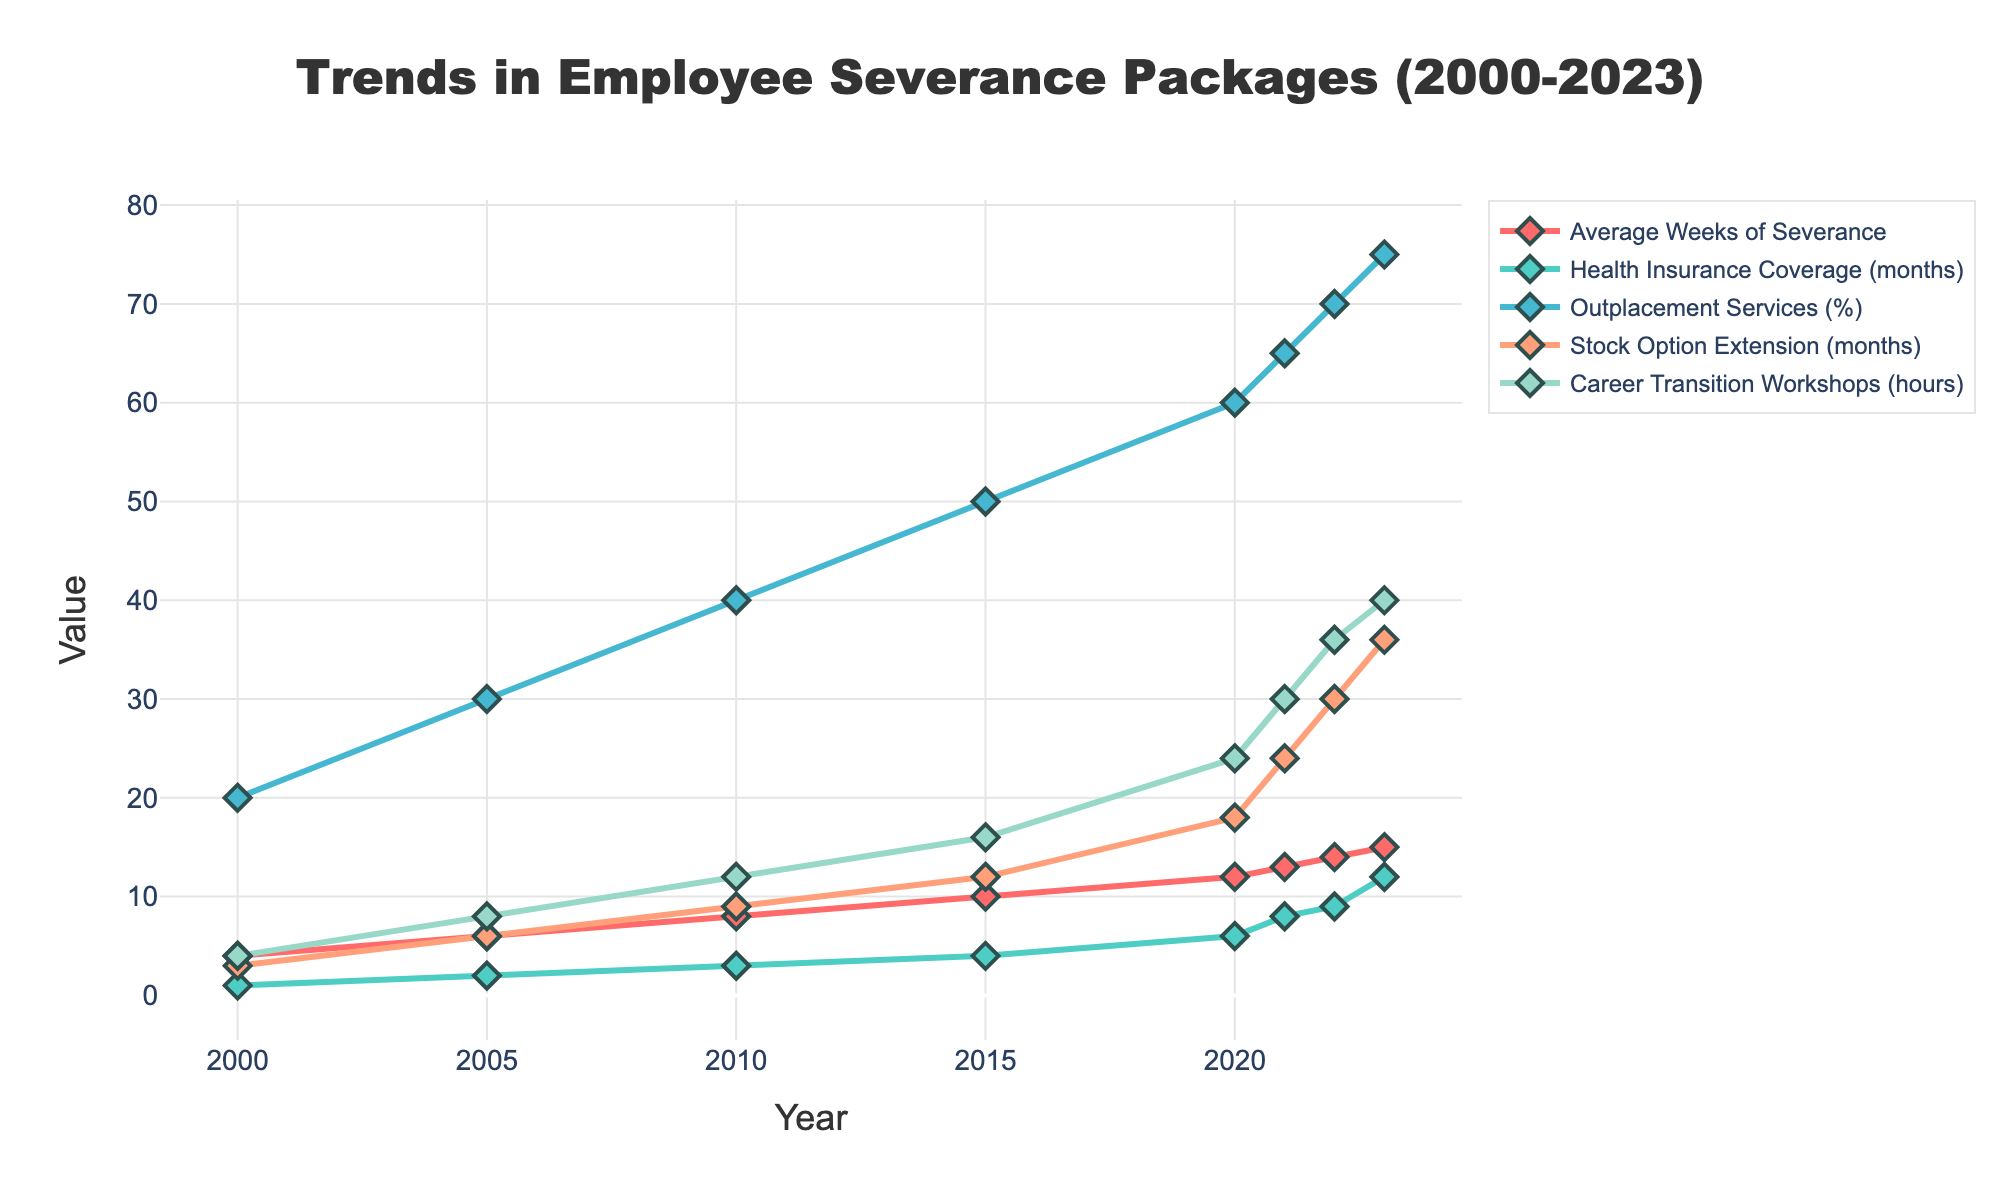how did the average weeks of severance change from 2000 to 2023? Look at the 'Average Weeks of Severance' line. In 2000 it was at 4 weeks, and by 2023, it had increased to 15 weeks. So the change is 15 weeks - 4 weeks = 11 weeks
Answer: Increased by 11 weeks Which year had the highest outplacement services? Look at the 'Outplacement Services (%)' line. The maximum peak in the graph is at the year 2023 with 75%.
Answer: 2023 What was the trend in health insurance coverage over the period? Refer to the 'Health Insurance Coverage (months)' line. Starting from 1 month in 2000, it gradually increased every year and reached 12 months by 2023.
Answer: Increased Which metric had the most significant increase in value from 2000 to 2023? Compare the value changes from 2000 to 2023 for each metric. 'Career Transition Workshops' went from 4 hours to 40 hours, a 36-hour increase. Other metrics increased less.
Answer: Career Transition Workshops How many more months of stock option extension were offered in 2023 compared to 2005? Look at the 'Stock Option Extension (months)' line for 2005 and 2023. In 2005, it was 6 months; in 2023, it was 36 months. The difference is 36 - 6 = 30 months.
Answer: 30 months How consistent was the growth in average weeks of severance over the years? Check the 'Average Weeks of Severance' line. Every 5 years, it increased by 2 weeks initially and then eventually by 1 week each subsequent year from 2020 onward. The growth was consistent.
Answer: Consistent Which metric showed the least improvement over the years? Compare the changes from 2000 to 2023 for each metric. 'Average Weeks of Severance' increased from 4 to 15 weeks, but this increase (11 weeks) is the smallest compared to other metrics' increases.
Answer: Average Weeks of Severance In which year did career transition workshops reach at least 30 hours? Check the 'Career Transition Workshops (hours)' line. It crossed 30 hours in the year 2021.
Answer: 2021 Was there any year where there was no change from the previous year in any of the metrics? Observe the year-to-year changes in all lines. Every metric shows some level of increase every year, so there was no period of stagnation.
Answer: No What is the sum of health insurance coverage months and stock option extension months in 2020? Check the values in 2020 for both metrics: health insurance coverage is 6 months, and stock option extension is 18 months. So the sum is 6 + 18 = 24 months.
Answer: 24 months 